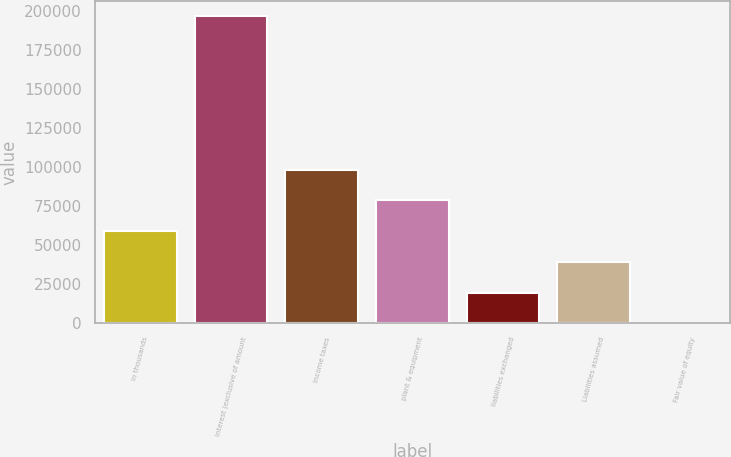Convert chart. <chart><loc_0><loc_0><loc_500><loc_500><bar_chart><fcel>in thousands<fcel>Interest (exclusive of amount<fcel>Income taxes<fcel>plant & equipment<fcel>liabilities exchanged<fcel>Liabilities assumed<fcel>Fair value of equity<nl><fcel>59040.6<fcel>196794<fcel>98398.7<fcel>78719.6<fcel>19682.4<fcel>39361.5<fcel>3.37<nl></chart> 